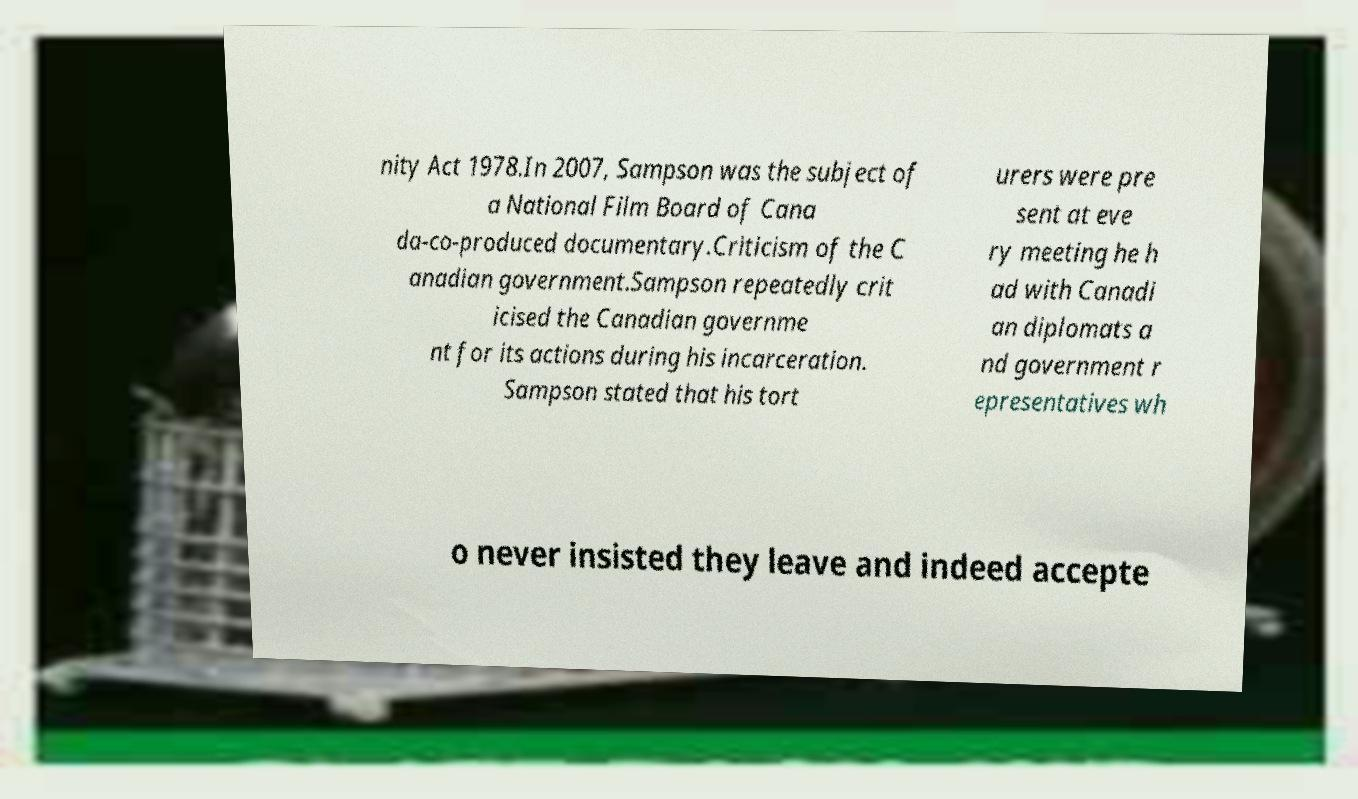Could you assist in decoding the text presented in this image and type it out clearly? nity Act 1978.In 2007, Sampson was the subject of a National Film Board of Cana da-co-produced documentary.Criticism of the C anadian government.Sampson repeatedly crit icised the Canadian governme nt for its actions during his incarceration. Sampson stated that his tort urers were pre sent at eve ry meeting he h ad with Canadi an diplomats a nd government r epresentatives wh o never insisted they leave and indeed accepte 